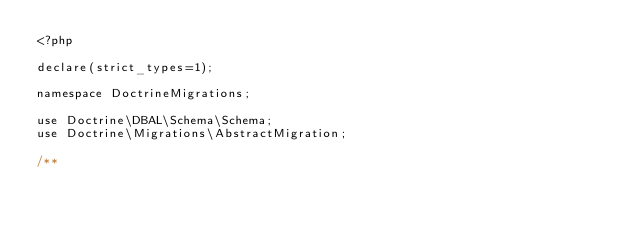Convert code to text. <code><loc_0><loc_0><loc_500><loc_500><_PHP_><?php

declare(strict_types=1);

namespace DoctrineMigrations;

use Doctrine\DBAL\Schema\Schema;
use Doctrine\Migrations\AbstractMigration;

/**</code> 